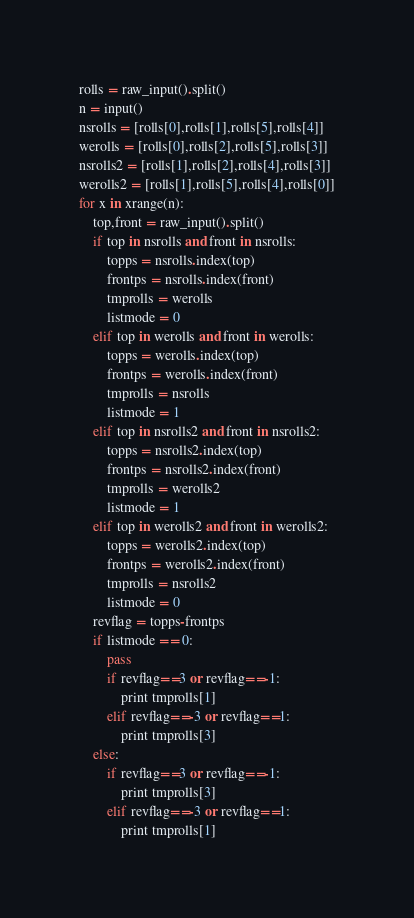<code> <loc_0><loc_0><loc_500><loc_500><_Python_>rolls = raw_input().split()
n = input()
nsrolls = [rolls[0],rolls[1],rolls[5],rolls[4]]
werolls = [rolls[0],rolls[2],rolls[5],rolls[3]]
nsrolls2 = [rolls[1],rolls[2],rolls[4],rolls[3]]
werolls2 = [rolls[1],rolls[5],rolls[4],rolls[0]]
for x in xrange(n):
    top,front = raw_input().split()
    if top in nsrolls and front in nsrolls:
        topps = nsrolls.index(top)
        frontps = nsrolls.index(front)
        tmprolls = werolls
        listmode = 0
    elif top in werolls and front in werolls:
        topps = werolls.index(top)
        frontps = werolls.index(front)
        tmprolls = nsrolls
        listmode = 1
    elif top in nsrolls2 and front in nsrolls2:
        topps = nsrolls2.index(top)
        frontps = nsrolls2.index(front)
        tmprolls = werolls2
        listmode = 1
    elif top in werolls2 and front in werolls2:
        topps = werolls2.index(top)
        frontps = werolls2.index(front)
        tmprolls = nsrolls2
        listmode = 0
    revflag = topps-frontps
    if listmode == 0:
        pass
        if revflag==3 or revflag==-1:
            print tmprolls[1]
        elif revflag==-3 or revflag==1:
            print tmprolls[3]
    else:
        if revflag==3 or revflag==-1:
            print tmprolls[3]
        elif revflag==-3 or revflag==1:
            print tmprolls[1]</code> 